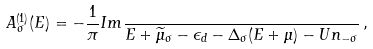Convert formula to latex. <formula><loc_0><loc_0><loc_500><loc_500>A ^ { ( 1 ) } _ { \sigma } ( E ) = - \frac { 1 } { \pi } I m \frac { } { E + \widetilde { \mu } _ { \sigma } - \epsilon _ { d } - \Delta _ { \sigma } ( E + \mu ) - U n _ { - \sigma } } \, ,</formula> 